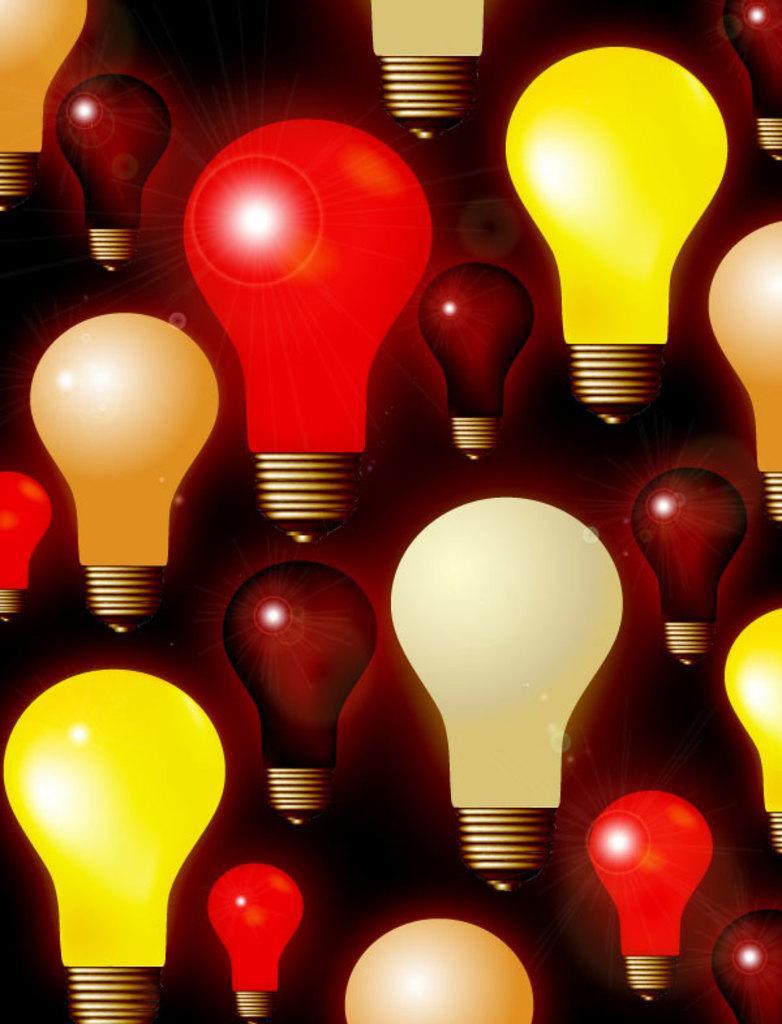In one or two sentences, can you explain what this image depicts? This is an animated picture. I can see colorful bulbs. 